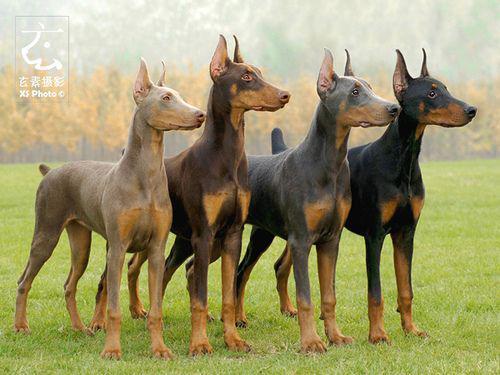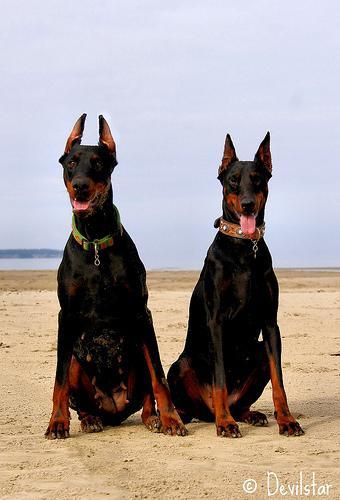The first image is the image on the left, the second image is the image on the right. For the images shown, is this caption "One black and one brown doberman pincer stand next to each other while they are outside." true? Answer yes or no. No. The first image is the image on the left, the second image is the image on the right. Considering the images on both sides, is "There are exactly four dogs in total." valid? Answer yes or no. No. 